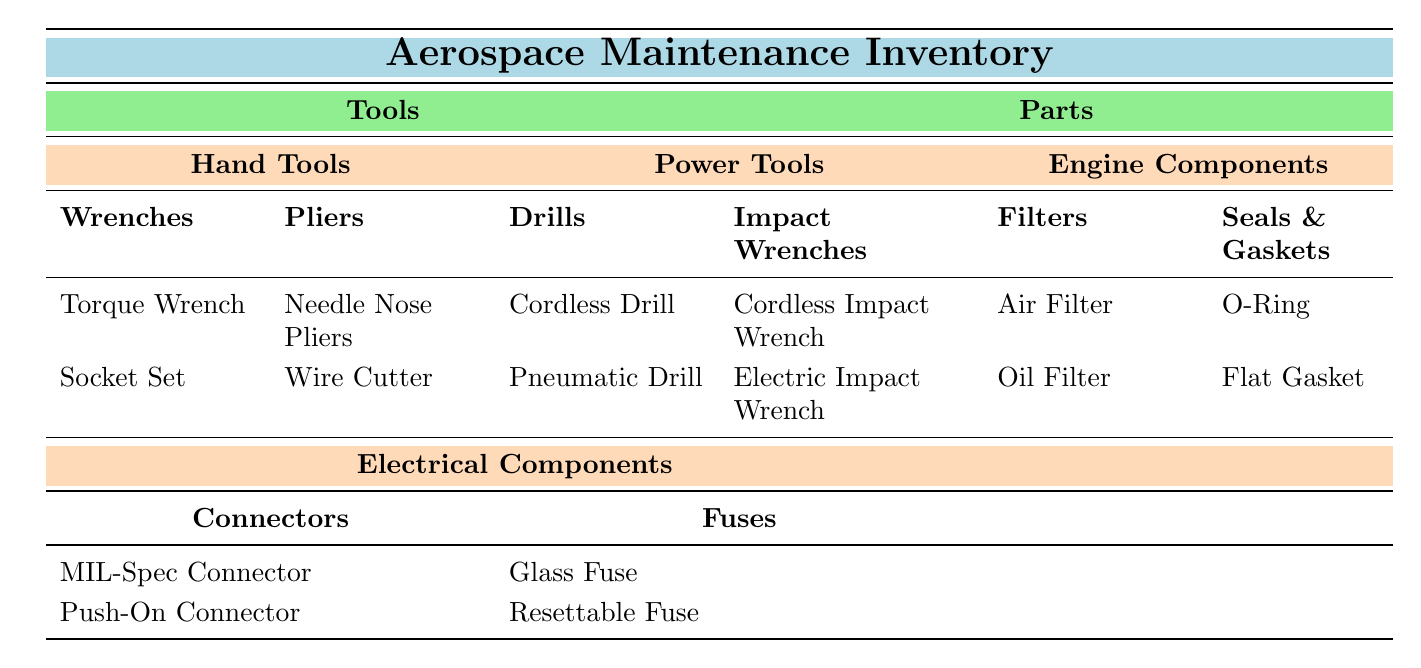What is the weight of the Torque Wrench? The Torque Wrench is listed in the Wrenches section under Hand Tools, and its weight is specifically mentioned in the table as 1.5 lbs.
Answer: 1.5 lbs What is the usage of the Cordless Drill? The Cordless Drill is included in the Drills section under Power Tools, and it states that its usage is for drilling holes in composite materials.
Answer: Drilling holes in composite materials Is the Push-On Connector made of metal? The Push-On Connector is listed under the Connectors section of Electrical Components, and its material is specified as Plastic and Brass, which indicates that it is not entirely metal.
Answer: No How many types of filters are listed for Engine Components? There are two types of filters listed in the Filters section under Engine Components: Air Filter and Oil Filter. Therefore, the count of different filter types is two.
Answer: 2 What is the total weight of the filters listed? The weight of the Air Filter is 2.0 lbs and the Oil Filter is 1.5 lbs. Adding these together gives a total weight of (2.0 + 1.5) = 3.5 lbs.
Answer: 3.5 lbs Are all hand tools made of steel? The table shows that there are various materials listed for hand tools: the Torque Wrench is made of Steel, the Socket Set of Chrome Vanadium, Needle Nose Pliers of Carbon Steel, and Wire Cutter of High Carbon Steel. Since there are tools made of different materials, not all are steel.
Answer: No What is the combined weight of the Cordless Impact Wrench and Electric Impact Wrench? The Cordless Impact Wrench weighs 3.8 lbs and the Electric Impact Wrench weighs 6.0 lbs. Adding these weights together gives (3.8 + 6.0) = 9.8 lbs.
Answer: 9.8 lbs Which tool is ideal for low visibility conditions? The Cordless Impact Wrench is specifically noted in the table for being ideal for low visibility conditions in its usage description.
Answer: Cordless Impact Wrench What material is the O-Ring made of? The O-Ring is listed under Seals and Gaskets in the Engine Components section, and it is specified that it is made of Nitrile Rubber.
Answer: Nitrile Rubber 